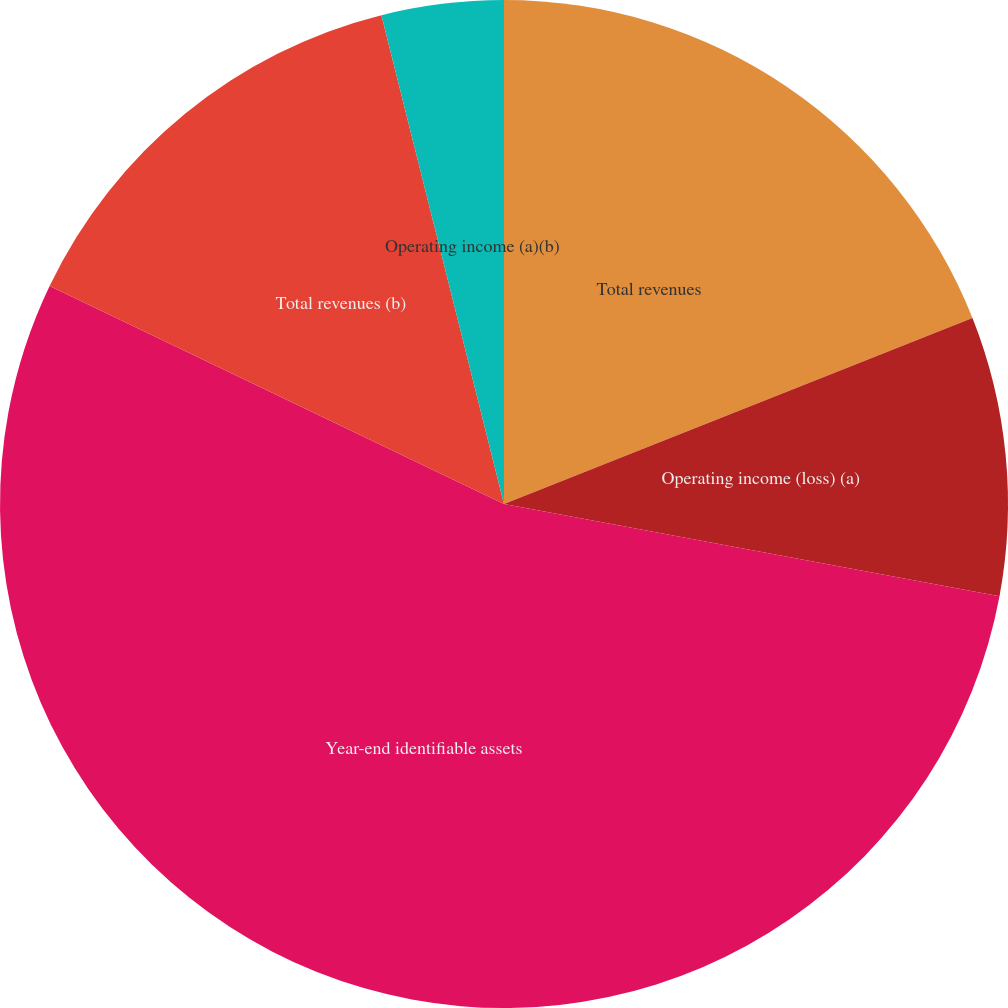<chart> <loc_0><loc_0><loc_500><loc_500><pie_chart><fcel>Total revenues<fcel>Operating income (loss) (a)<fcel>Year-end identifiable assets<fcel>Total revenues (b)<fcel>Operating income (a)(b)<nl><fcel>18.99%<fcel>8.94%<fcel>54.2%<fcel>13.97%<fcel>3.91%<nl></chart> 